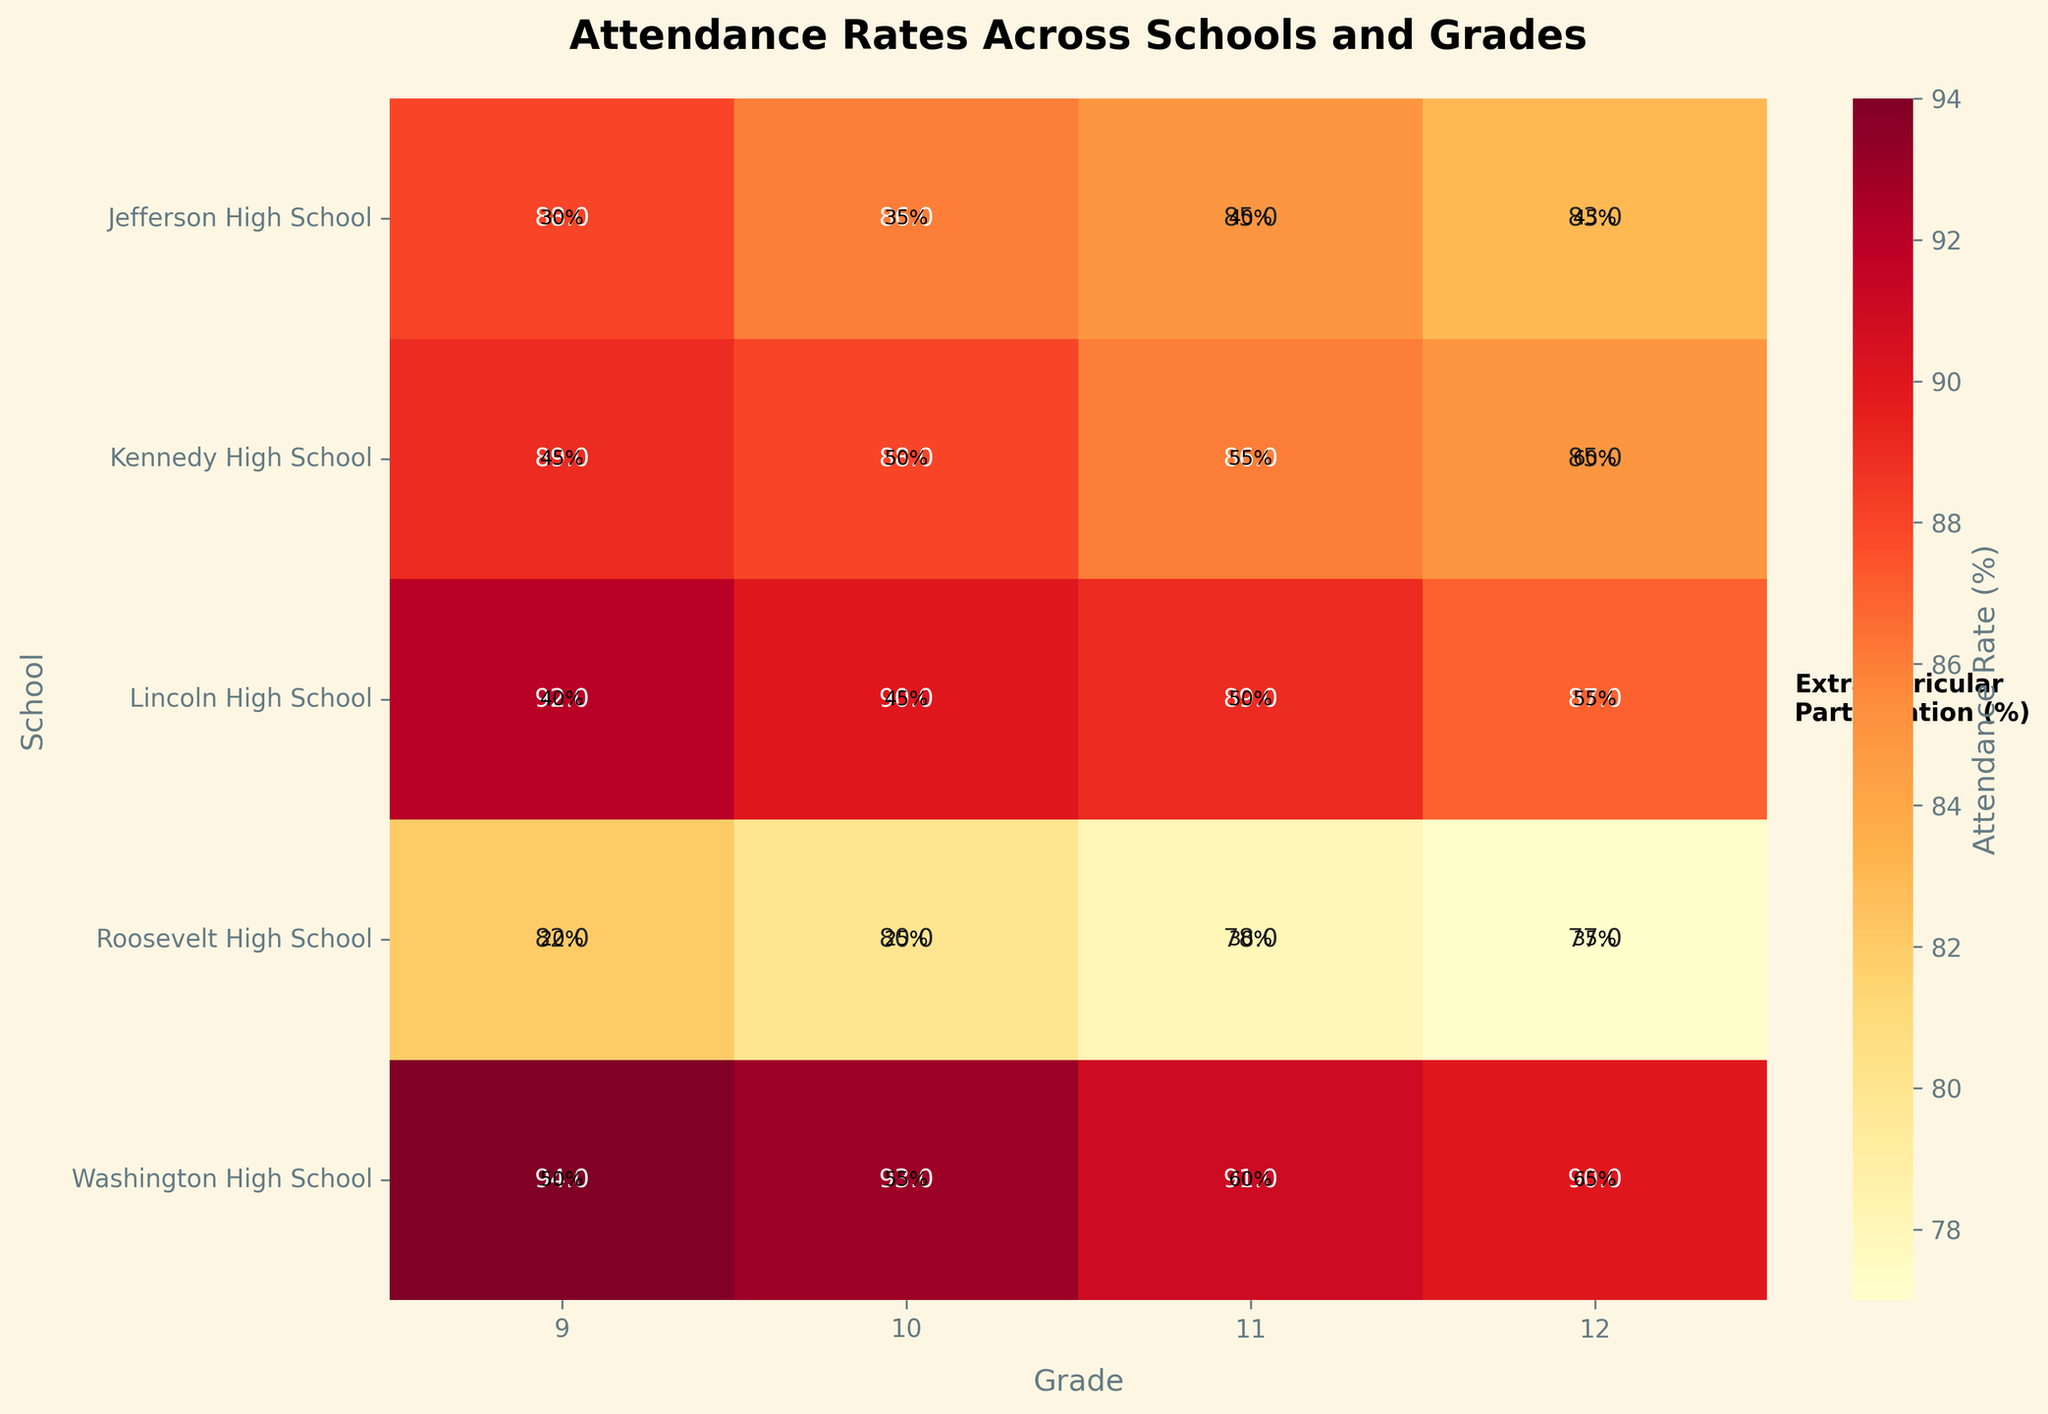What is the title of the heatmap? The title is located at the top of the heatmap. It is typically in a larger, bold font for easy identification.
Answer: Attendance Rates Across Schools and Grades Which school has the highest attendance rate for Grade 9? Look at the column labeled "9" (Grade 9) and find the cell with the highest value. The corresponding row gives you the school.
Answer: Washington High School What is the attendance rate for Lincoln High School in Grade 11? Locate the row for Lincoln High School and the column for Grade 11. The value in the cell where the row and column intersect is the attendance rate.
Answer: 89% What is the average attendance rate for all grades in Jefferson High School? Find the row for Jefferson High School and average the values across the columns labeled 9, 10, 11, and 12.
Answer: (88 + 86 + 85 + 83) / 4 = 85.5% Which grade shows the highest range in attendance rates across all schools? For each grade column (9, 10, 11, 12), calculate the difference between the highest and lowest attendance rates and compare these ranges.
Answer: Grade 9 Is there a noticeable trend in attendance rates as students progress through grades within Lincoln High School? Look down the row for Lincoln High School and observe how the attendance rates change from Grade 9 to Grade 12.
Answer: Yes, it declines from 92% to 87% Which school has the lowest participation in extracurricular activities for Grade 12? Look at the text annotations for Grade 12 across all schools, and find the lowest percentage. The corresponding row gives you the school.
Answer: Roosevelt High School Between Jefferson High School and Kennedy High School, which one has a higher average attendance rate in Grade 10? Compare the attendance rates for Grade 10 in the rows for Jefferson High School and Kennedy High School.
Answer: Kennedy High School Across all grades, which school has the most consistent (smallest variation) attendance rates? Calculate the variance of attendance rates for each school's row and identify the one with the smallest variance.
Answer: Kennedy High School What is the correlation between extracurricular participation and attendance rates in Washington High School? Observe the relationship by looking at the rows for Washington High School. Note how attendance rates change with participation rates.
Answer: Positive correlation: as participation increases, attendance rates are generally high 